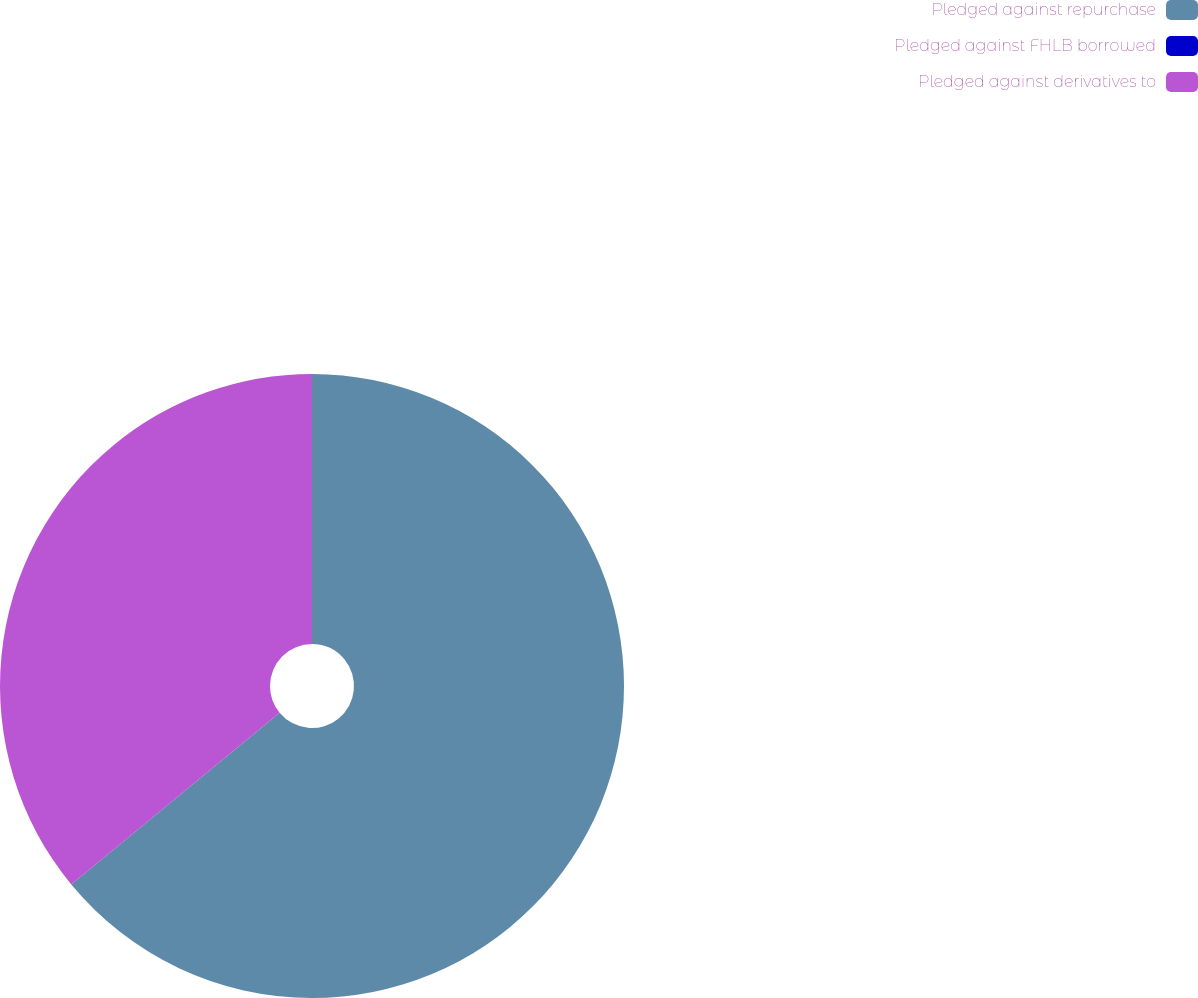Convert chart to OTSL. <chart><loc_0><loc_0><loc_500><loc_500><pie_chart><fcel>Pledged against repurchase<fcel>Pledged against FHLB borrowed<fcel>Pledged against derivatives to<nl><fcel>64.02%<fcel>0.01%<fcel>35.97%<nl></chart> 